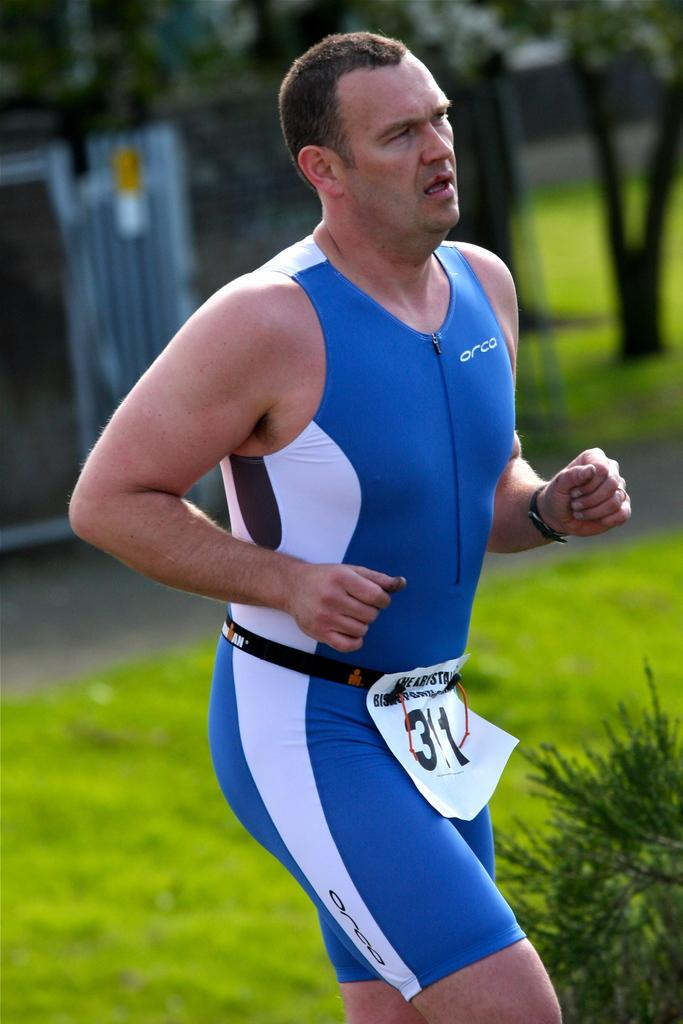<image>
Offer a succinct explanation of the picture presented. A man wearing a blue Orca running suit. 